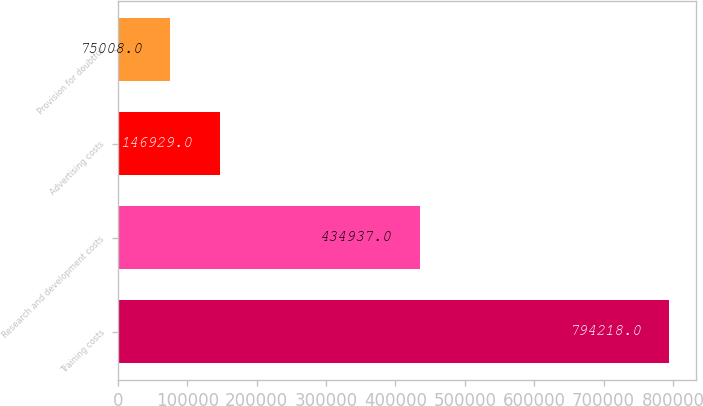<chart> <loc_0><loc_0><loc_500><loc_500><bar_chart><fcel>Training costs<fcel>Research and development costs<fcel>Advertising costs<fcel>Provision for doubtful<nl><fcel>794218<fcel>434937<fcel>146929<fcel>75008<nl></chart> 